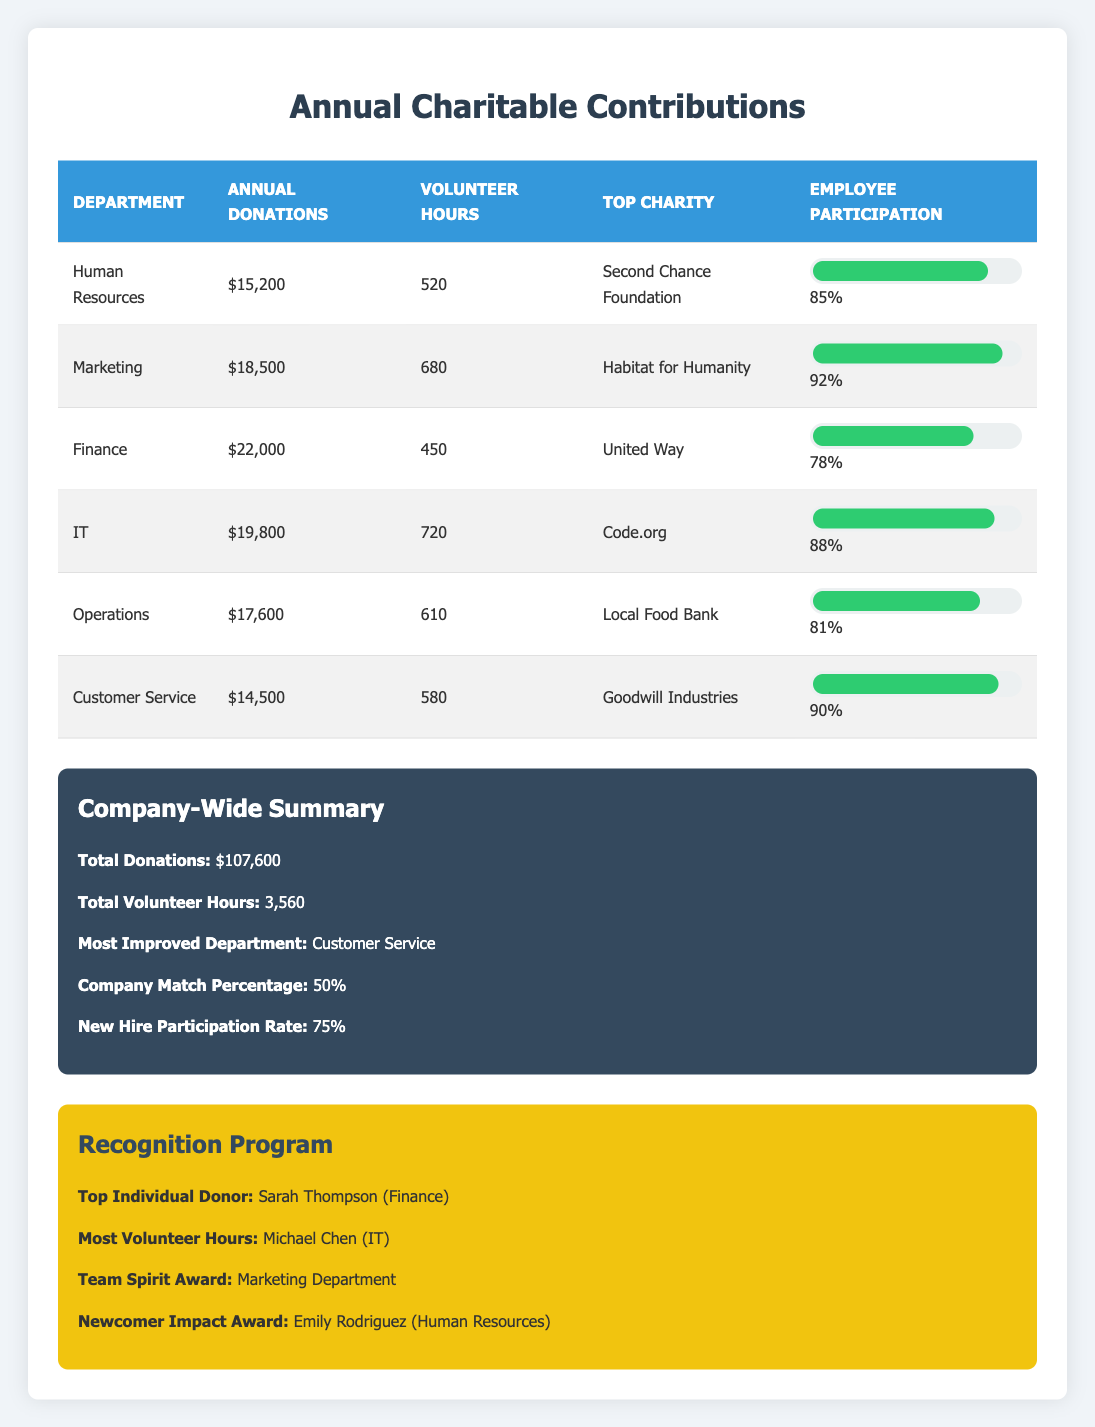What are the annual donations made by the IT department? The table shows that the IT department's annual donations are listed as $19,800.
Answer: $19,800 Which department has the highest volunteer hours? By examining the volunteer hours column, the IT department has the highest volunteer hours at 720.
Answer: IT department What is the total amount of annual donations made by all departments combined? To find the total donations, we can add the yearly contributions from each department: 15,200 + 18,500 + 22,000 + 19,800 + 17,600 + 14,500 = 107,600.
Answer: $107,600 Does the Customer Service department have a higher or lower employee participation rate than the Finance department? The employee participation rate for Customer Service is 0.90 (90%) and for Finance is 0.78 (78%). Since 0.90 is greater than 0.78, the Customer Service department has a higher rate.
Answer: Higher Which department contributed to "Goodwill Industries"? The Customer Service department is noted in the table for its contributions to Goodwill Industries.
Answer: Customer Service department What is the average employee participation rate across all departments? To calculate the average, sum the participation rates: 0.85 + 0.92 + 0.78 + 0.88 + 0.81 + 0.90 = 5.14 and then divide by the number of departments (6). Thus, the average is 5.14 / 6 = 0.857 or 85.7%.
Answer: 85.7% Which department made the least amount of annual donations? By comparing the annual donations of all departments, Customer Service made the least amount at $14,500.
Answer: Customer Service Did the Marketing department receive the Team Spirit Award? The table indicates that the Marketing department is indeed recognized with the Team Spirit Award.
Answer: Yes Which charity did the Operations department support? The Operations department’s top charity listed in the table is the Local Food Bank.
Answer: Local Food Bank 